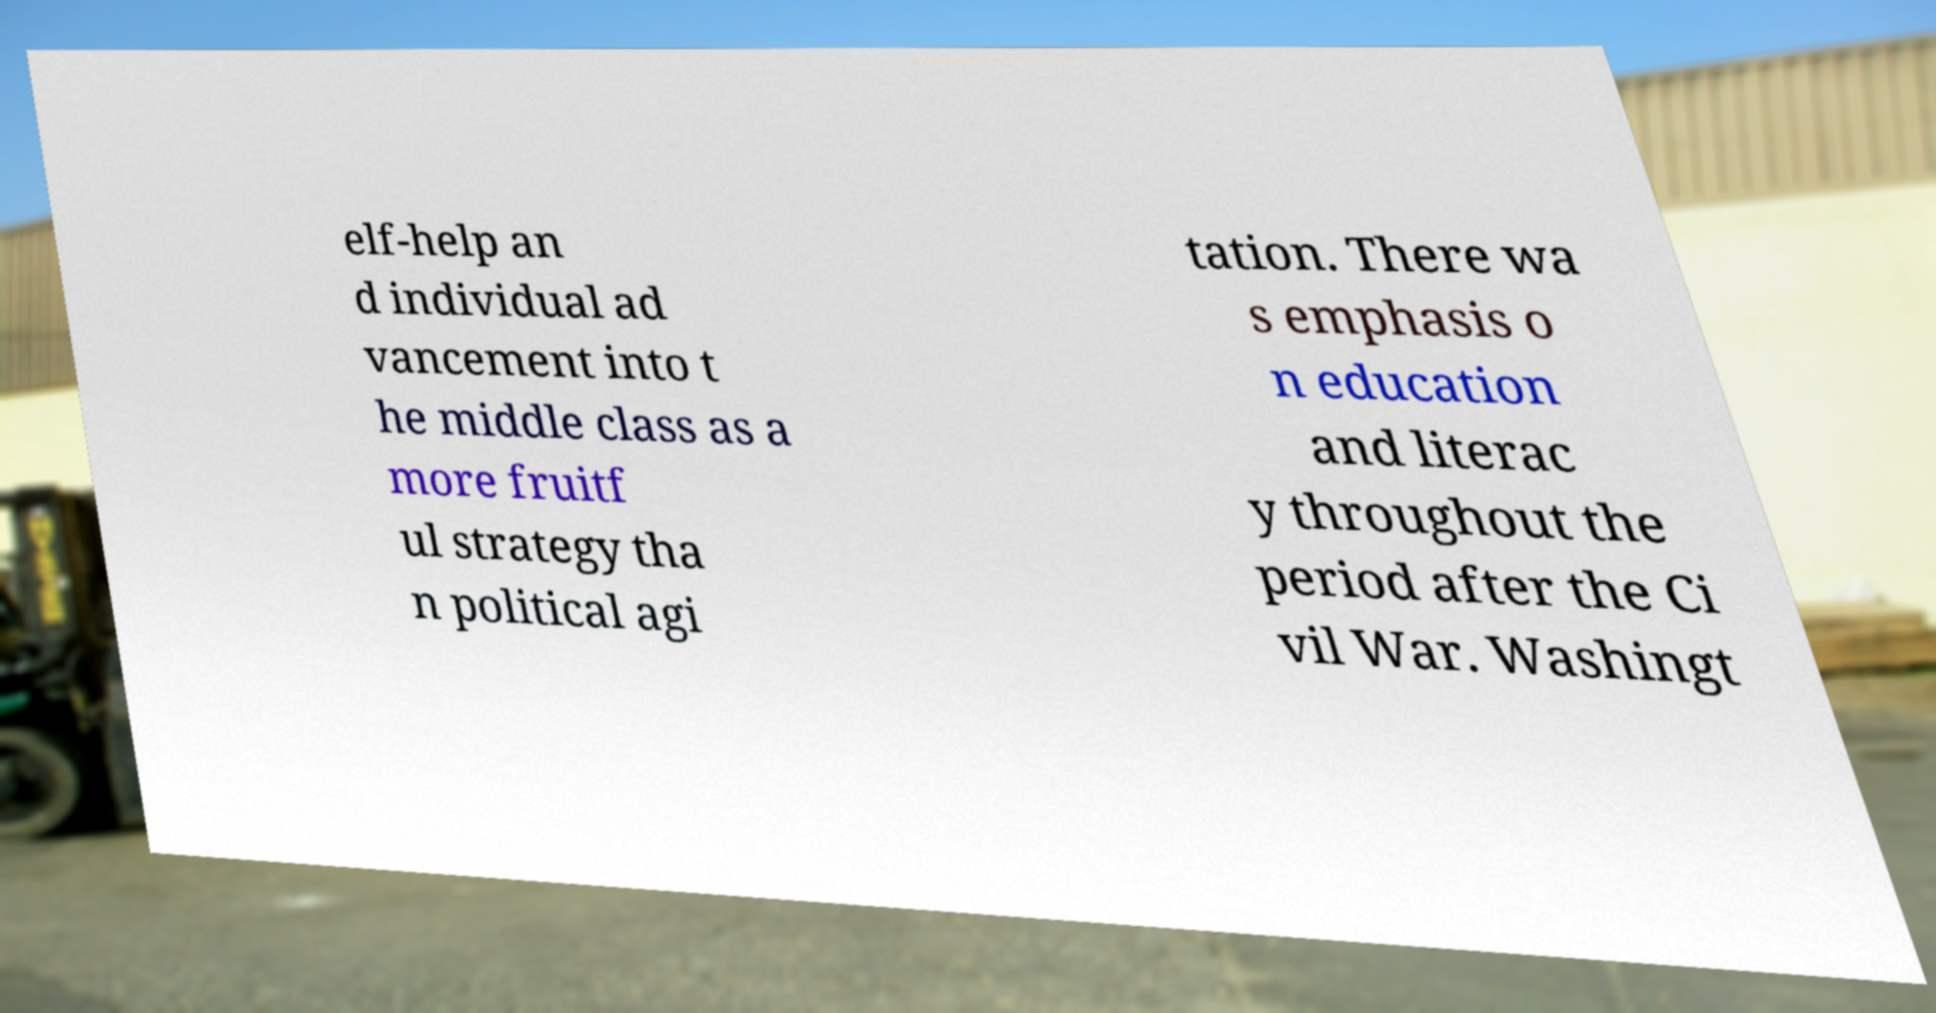Could you extract and type out the text from this image? elf-help an d individual ad vancement into t he middle class as a more fruitf ul strategy tha n political agi tation. There wa s emphasis o n education and literac y throughout the period after the Ci vil War. Washingt 